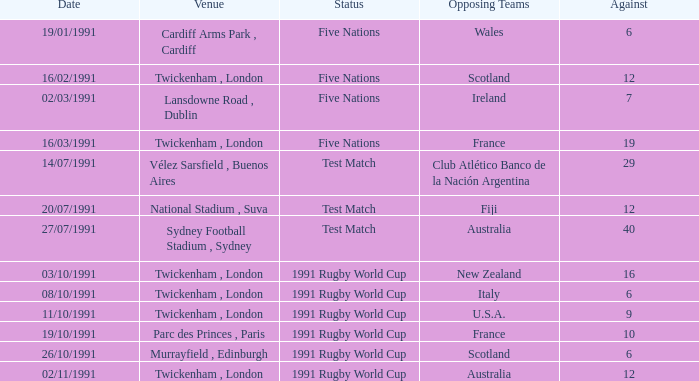What is Opposing Teams, when Date is "11/10/1991"? U.S.A. 